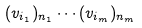Convert formula to latex. <formula><loc_0><loc_0><loc_500><loc_500>( v _ { i _ { 1 } } ) _ { n _ { 1 } } \cdots ( v _ { i _ { m } } ) _ { n _ { m } }</formula> 